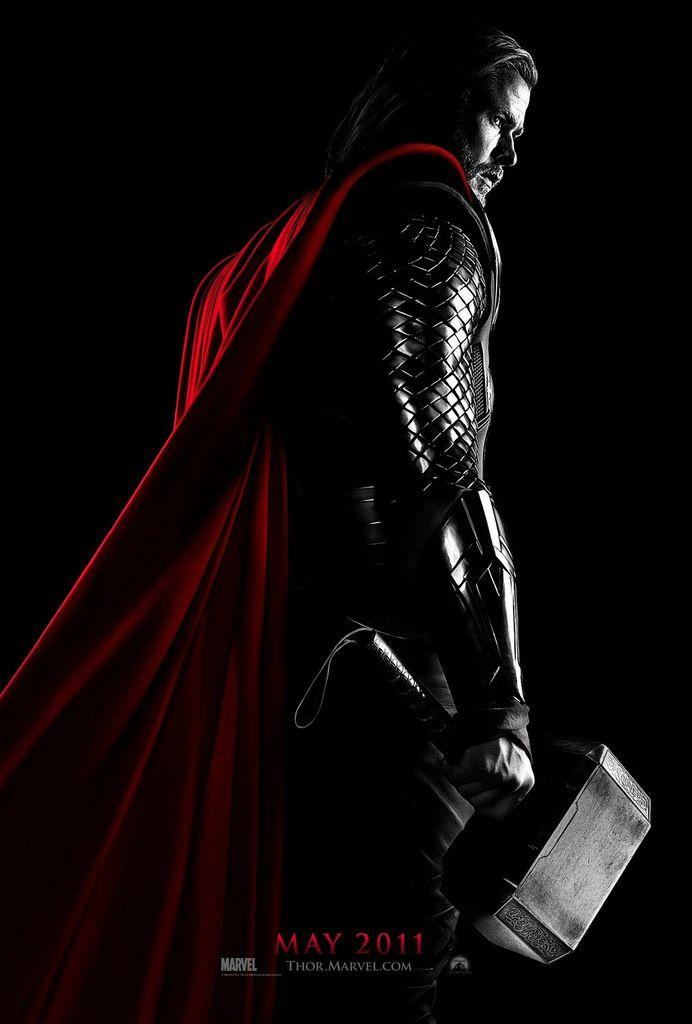Who or what is the main subject in the image? There is a person in the image. What is the person holding in the image? The person is holding a hammer. Where is the person and the hammer located in the image? The person and the hammer are in the center of the image. What type of gold curve can be seen in the image? There is no gold curve present in the image. 